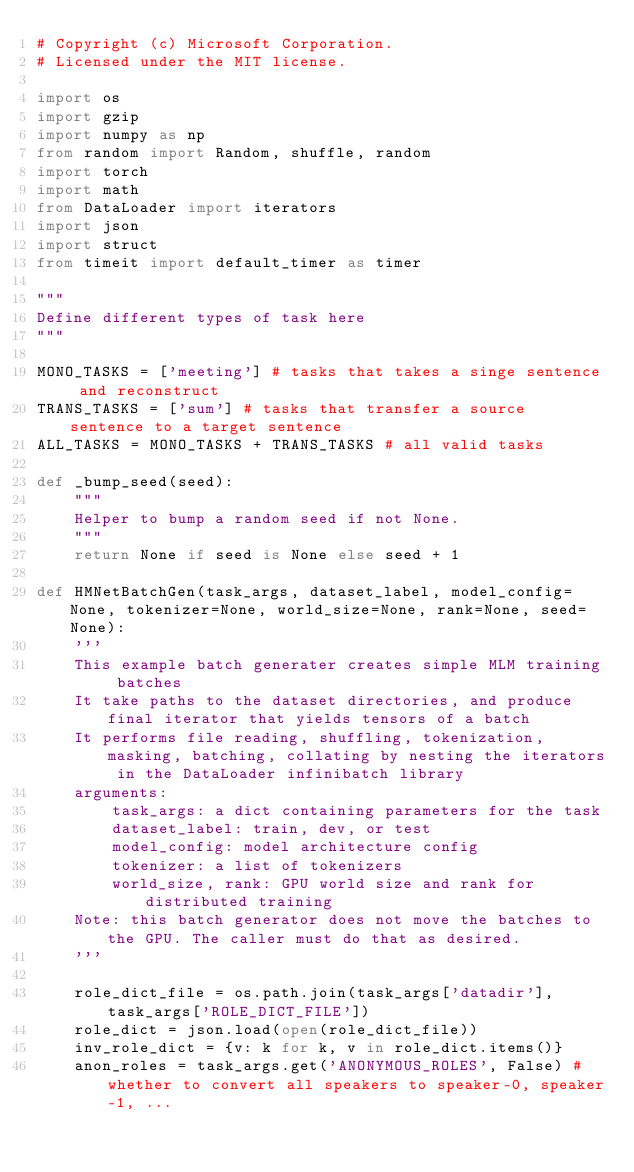Convert code to text. <code><loc_0><loc_0><loc_500><loc_500><_Python_># Copyright (c) Microsoft Corporation.
# Licensed under the MIT license.

import os
import gzip
import numpy as np
from random import Random, shuffle, random
import torch
import math
from DataLoader import iterators
import json
import struct
from timeit import default_timer as timer

"""
Define different types of task here
"""

MONO_TASKS = ['meeting'] # tasks that takes a singe sentence and reconstruct
TRANS_TASKS = ['sum'] # tasks that transfer a source sentence to a target sentence
ALL_TASKS = MONO_TASKS + TRANS_TASKS # all valid tasks

def _bump_seed(seed):
    """
    Helper to bump a random seed if not None.
    """
    return None if seed is None else seed + 1

def HMNetBatchGen(task_args, dataset_label, model_config=None, tokenizer=None, world_size=None, rank=None, seed=None):
    '''
    This example batch generater creates simple MLM training batches
    It take paths to the dataset directories, and produce final iterator that yields tensors of a batch
    It performs file reading, shuffling, tokenization, masking, batching, collating by nesting the iterators in the DataLoader infinibatch library
    arguments:
        task_args: a dict containing parameters for the task
        dataset_label: train, dev, or test
        model_config: model architecture config
        tokenizer: a list of tokenizers
        world_size, rank: GPU world size and rank for distributed training
    Note: this batch generator does not move the batches to the GPU. The caller must do that as desired.
    '''

    role_dict_file = os.path.join(task_args['datadir'], task_args['ROLE_DICT_FILE'])
    role_dict = json.load(open(role_dict_file))
    inv_role_dict = {v: k for k, v in role_dict.items()}
    anon_roles = task_args.get('ANONYMOUS_ROLES', False) # whether to convert all speakers to speaker-0, speaker-1, ...
</code> 